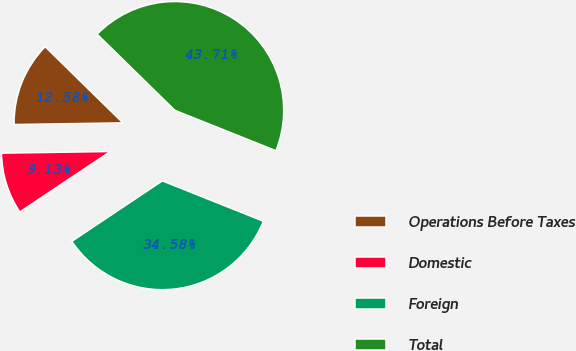Convert chart. <chart><loc_0><loc_0><loc_500><loc_500><pie_chart><fcel>Operations Before Taxes<fcel>Domestic<fcel>Foreign<fcel>Total<nl><fcel>12.58%<fcel>9.13%<fcel>34.58%<fcel>43.71%<nl></chart> 